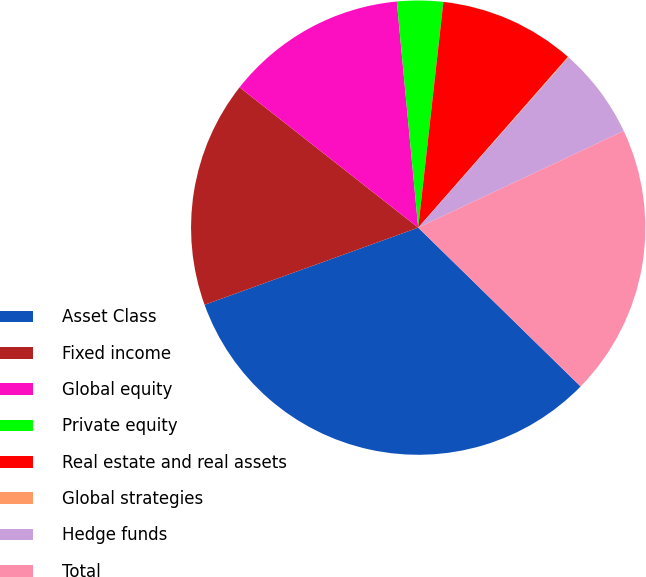Convert chart to OTSL. <chart><loc_0><loc_0><loc_500><loc_500><pie_chart><fcel>Asset Class<fcel>Fixed income<fcel>Global equity<fcel>Private equity<fcel>Real estate and real assets<fcel>Global strategies<fcel>Hedge funds<fcel>Total<nl><fcel>32.16%<fcel>16.11%<fcel>12.9%<fcel>3.27%<fcel>9.69%<fcel>0.06%<fcel>6.48%<fcel>19.32%<nl></chart> 